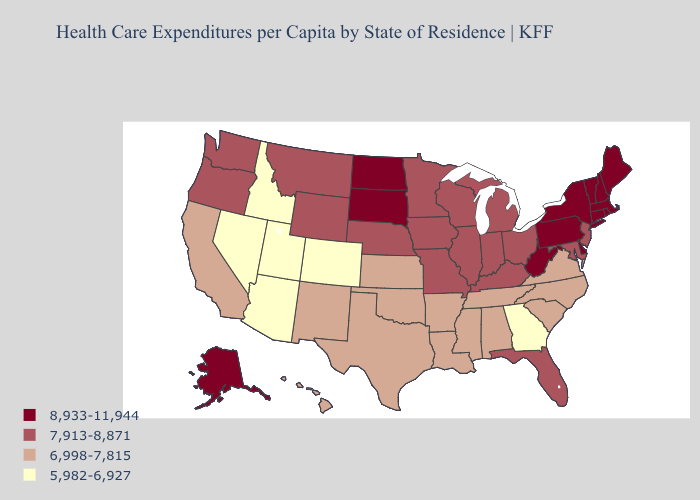Does Missouri have a higher value than Maine?
Answer briefly. No. Name the states that have a value in the range 8,933-11,944?
Give a very brief answer. Alaska, Connecticut, Delaware, Maine, Massachusetts, New Hampshire, New York, North Dakota, Pennsylvania, Rhode Island, South Dakota, Vermont, West Virginia. What is the value of Colorado?
Write a very short answer. 5,982-6,927. Is the legend a continuous bar?
Give a very brief answer. No. How many symbols are there in the legend?
Be succinct. 4. Name the states that have a value in the range 8,933-11,944?
Keep it brief. Alaska, Connecticut, Delaware, Maine, Massachusetts, New Hampshire, New York, North Dakota, Pennsylvania, Rhode Island, South Dakota, Vermont, West Virginia. Does Rhode Island have the lowest value in the Northeast?
Write a very short answer. No. Name the states that have a value in the range 5,982-6,927?
Write a very short answer. Arizona, Colorado, Georgia, Idaho, Nevada, Utah. Does Alabama have the same value as Minnesota?
Concise answer only. No. Name the states that have a value in the range 8,933-11,944?
Give a very brief answer. Alaska, Connecticut, Delaware, Maine, Massachusetts, New Hampshire, New York, North Dakota, Pennsylvania, Rhode Island, South Dakota, Vermont, West Virginia. What is the lowest value in states that border Rhode Island?
Write a very short answer. 8,933-11,944. What is the highest value in the USA?
Quick response, please. 8,933-11,944. What is the value of Wyoming?
Quick response, please. 7,913-8,871. What is the value of Illinois?
Be succinct. 7,913-8,871. What is the value of New York?
Keep it brief. 8,933-11,944. 